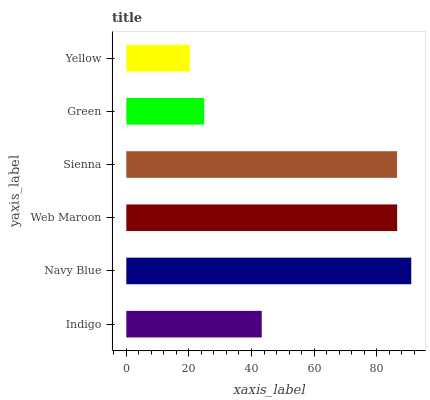Is Yellow the minimum?
Answer yes or no. Yes. Is Navy Blue the maximum?
Answer yes or no. Yes. Is Web Maroon the minimum?
Answer yes or no. No. Is Web Maroon the maximum?
Answer yes or no. No. Is Navy Blue greater than Web Maroon?
Answer yes or no. Yes. Is Web Maroon less than Navy Blue?
Answer yes or no. Yes. Is Web Maroon greater than Navy Blue?
Answer yes or no. No. Is Navy Blue less than Web Maroon?
Answer yes or no. No. Is Sienna the high median?
Answer yes or no. Yes. Is Indigo the low median?
Answer yes or no. Yes. Is Navy Blue the high median?
Answer yes or no. No. Is Yellow the low median?
Answer yes or no. No. 